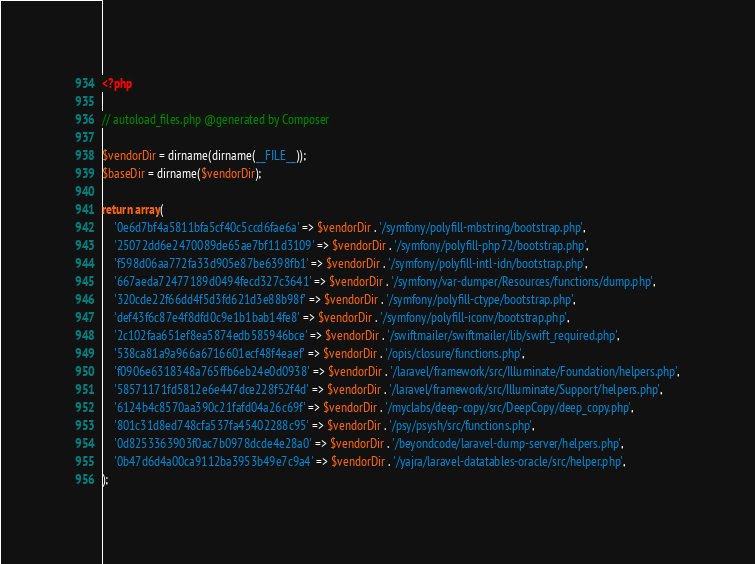<code> <loc_0><loc_0><loc_500><loc_500><_PHP_><?php

// autoload_files.php @generated by Composer

$vendorDir = dirname(dirname(__FILE__));
$baseDir = dirname($vendorDir);

return array(
    '0e6d7bf4a5811bfa5cf40c5ccd6fae6a' => $vendorDir . '/symfony/polyfill-mbstring/bootstrap.php',
    '25072dd6e2470089de65ae7bf11d3109' => $vendorDir . '/symfony/polyfill-php72/bootstrap.php',
    'f598d06aa772fa33d905e87be6398fb1' => $vendorDir . '/symfony/polyfill-intl-idn/bootstrap.php',
    '667aeda72477189d0494fecd327c3641' => $vendorDir . '/symfony/var-dumper/Resources/functions/dump.php',
    '320cde22f66dd4f5d3fd621d3e88b98f' => $vendorDir . '/symfony/polyfill-ctype/bootstrap.php',
    'def43f6c87e4f8dfd0c9e1b1bab14fe8' => $vendorDir . '/symfony/polyfill-iconv/bootstrap.php',
    '2c102faa651ef8ea5874edb585946bce' => $vendorDir . '/swiftmailer/swiftmailer/lib/swift_required.php',
    '538ca81a9a966a6716601ecf48f4eaef' => $vendorDir . '/opis/closure/functions.php',
    'f0906e6318348a765ffb6eb24e0d0938' => $vendorDir . '/laravel/framework/src/Illuminate/Foundation/helpers.php',
    '58571171fd5812e6e447dce228f52f4d' => $vendorDir . '/laravel/framework/src/Illuminate/Support/helpers.php',
    '6124b4c8570aa390c21fafd04a26c69f' => $vendorDir . '/myclabs/deep-copy/src/DeepCopy/deep_copy.php',
    '801c31d8ed748cfa537fa45402288c95' => $vendorDir . '/psy/psysh/src/functions.php',
    '0d8253363903f0ac7b0978dcde4e28a0' => $vendorDir . '/beyondcode/laravel-dump-server/helpers.php',
    '0b47d6d4a00ca9112ba3953b49e7c9a4' => $vendorDir . '/yajra/laravel-datatables-oracle/src/helper.php',
);
</code> 